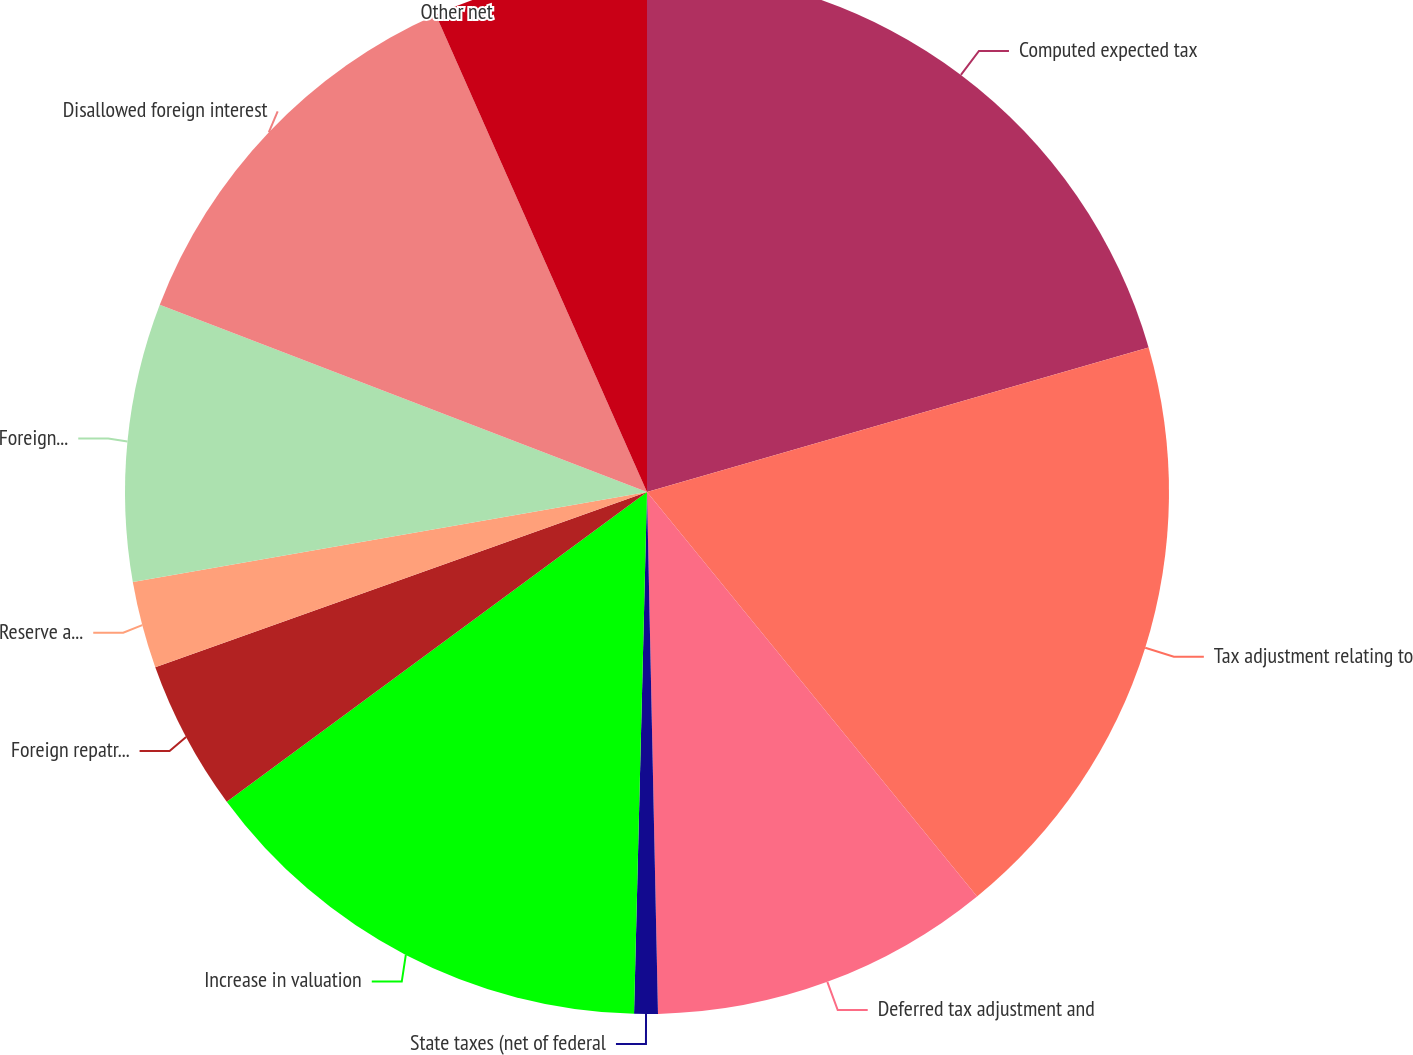<chart> <loc_0><loc_0><loc_500><loc_500><pie_chart><fcel>Computed expected tax<fcel>Tax adjustment relating to<fcel>Deferred tax adjustment and<fcel>State taxes (net of federal<fcel>Increase in valuation<fcel>Foreign repatriation<fcel>Reserve accrual (reversal) and<fcel>Foreign tax rate differential<fcel>Disallowed foreign interest<fcel>Other net<nl><fcel>20.54%<fcel>18.57%<fcel>10.56%<fcel>0.73%<fcel>14.5%<fcel>4.66%<fcel>2.69%<fcel>8.6%<fcel>12.53%<fcel>6.63%<nl></chart> 